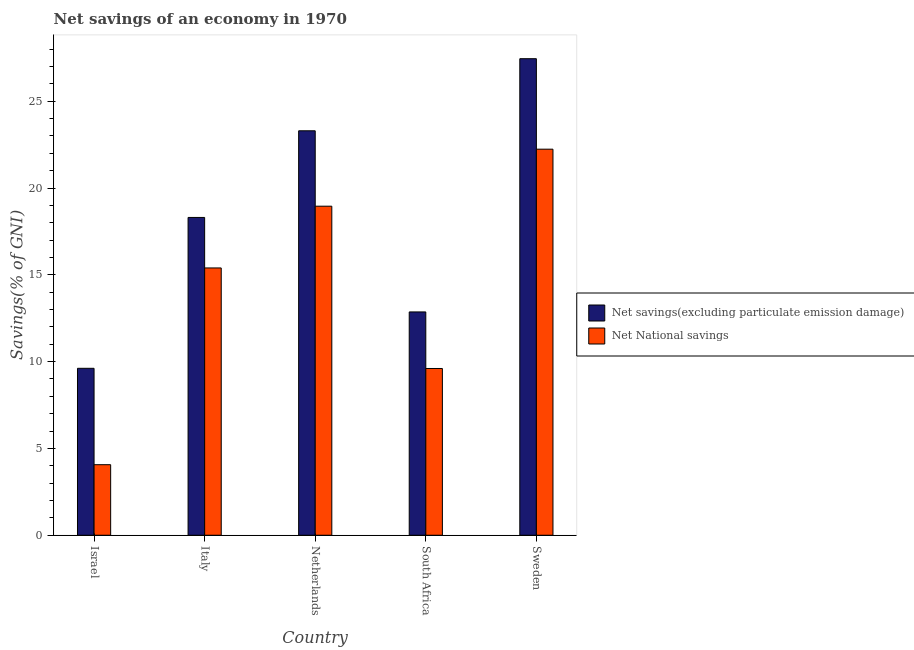How many different coloured bars are there?
Ensure brevity in your answer.  2. How many groups of bars are there?
Offer a terse response. 5. Are the number of bars per tick equal to the number of legend labels?
Provide a succinct answer. Yes. Are the number of bars on each tick of the X-axis equal?
Offer a terse response. Yes. How many bars are there on the 5th tick from the right?
Provide a succinct answer. 2. What is the label of the 5th group of bars from the left?
Give a very brief answer. Sweden. In how many cases, is the number of bars for a given country not equal to the number of legend labels?
Your answer should be compact. 0. What is the net savings(excluding particulate emission damage) in Netherlands?
Your answer should be very brief. 23.3. Across all countries, what is the maximum net national savings?
Keep it short and to the point. 22.24. Across all countries, what is the minimum net savings(excluding particulate emission damage)?
Your response must be concise. 9.61. In which country was the net savings(excluding particulate emission damage) maximum?
Your answer should be compact. Sweden. What is the total net savings(excluding particulate emission damage) in the graph?
Offer a terse response. 91.52. What is the difference between the net national savings in Italy and that in South Africa?
Keep it short and to the point. 5.79. What is the difference between the net national savings in Sweden and the net savings(excluding particulate emission damage) in South Africa?
Offer a terse response. 9.37. What is the average net savings(excluding particulate emission damage) per country?
Your answer should be very brief. 18.3. What is the difference between the net national savings and net savings(excluding particulate emission damage) in Italy?
Keep it short and to the point. -2.91. What is the ratio of the net savings(excluding particulate emission damage) in Italy to that in South Africa?
Your answer should be very brief. 1.42. Is the difference between the net savings(excluding particulate emission damage) in Israel and South Africa greater than the difference between the net national savings in Israel and South Africa?
Your answer should be compact. Yes. What is the difference between the highest and the second highest net national savings?
Your response must be concise. 3.28. What is the difference between the highest and the lowest net savings(excluding particulate emission damage)?
Your answer should be compact. 17.83. In how many countries, is the net national savings greater than the average net national savings taken over all countries?
Offer a terse response. 3. What does the 1st bar from the left in Sweden represents?
Your answer should be compact. Net savings(excluding particulate emission damage). What does the 2nd bar from the right in Italy represents?
Your answer should be very brief. Net savings(excluding particulate emission damage). How many bars are there?
Make the answer very short. 10. How many countries are there in the graph?
Your answer should be very brief. 5. What is the difference between two consecutive major ticks on the Y-axis?
Your answer should be compact. 5. Are the values on the major ticks of Y-axis written in scientific E-notation?
Keep it short and to the point. No. Does the graph contain any zero values?
Your answer should be very brief. No. Where does the legend appear in the graph?
Your answer should be very brief. Center right. How many legend labels are there?
Ensure brevity in your answer.  2. What is the title of the graph?
Your answer should be very brief. Net savings of an economy in 1970. What is the label or title of the X-axis?
Offer a terse response. Country. What is the label or title of the Y-axis?
Give a very brief answer. Savings(% of GNI). What is the Savings(% of GNI) in Net savings(excluding particulate emission damage) in Israel?
Offer a very short reply. 9.61. What is the Savings(% of GNI) in Net National savings in Israel?
Provide a succinct answer. 4.06. What is the Savings(% of GNI) in Net savings(excluding particulate emission damage) in Italy?
Keep it short and to the point. 18.3. What is the Savings(% of GNI) in Net National savings in Italy?
Offer a very short reply. 15.4. What is the Savings(% of GNI) in Net savings(excluding particulate emission damage) in Netherlands?
Provide a succinct answer. 23.3. What is the Savings(% of GNI) of Net National savings in Netherlands?
Make the answer very short. 18.95. What is the Savings(% of GNI) of Net savings(excluding particulate emission damage) in South Africa?
Your answer should be compact. 12.86. What is the Savings(% of GNI) of Net National savings in South Africa?
Make the answer very short. 9.6. What is the Savings(% of GNI) in Net savings(excluding particulate emission damage) in Sweden?
Offer a very short reply. 27.45. What is the Savings(% of GNI) in Net National savings in Sweden?
Offer a very short reply. 22.24. Across all countries, what is the maximum Savings(% of GNI) of Net savings(excluding particulate emission damage)?
Offer a terse response. 27.45. Across all countries, what is the maximum Savings(% of GNI) in Net National savings?
Give a very brief answer. 22.24. Across all countries, what is the minimum Savings(% of GNI) of Net savings(excluding particulate emission damage)?
Offer a very short reply. 9.61. Across all countries, what is the minimum Savings(% of GNI) of Net National savings?
Your response must be concise. 4.06. What is the total Savings(% of GNI) in Net savings(excluding particulate emission damage) in the graph?
Your answer should be compact. 91.52. What is the total Savings(% of GNI) of Net National savings in the graph?
Offer a very short reply. 70.25. What is the difference between the Savings(% of GNI) of Net savings(excluding particulate emission damage) in Israel and that in Italy?
Provide a succinct answer. -8.69. What is the difference between the Savings(% of GNI) in Net National savings in Israel and that in Italy?
Give a very brief answer. -11.33. What is the difference between the Savings(% of GNI) in Net savings(excluding particulate emission damage) in Israel and that in Netherlands?
Your answer should be very brief. -13.68. What is the difference between the Savings(% of GNI) of Net National savings in Israel and that in Netherlands?
Provide a succinct answer. -14.89. What is the difference between the Savings(% of GNI) of Net savings(excluding particulate emission damage) in Israel and that in South Africa?
Offer a very short reply. -3.25. What is the difference between the Savings(% of GNI) of Net National savings in Israel and that in South Africa?
Your response must be concise. -5.54. What is the difference between the Savings(% of GNI) in Net savings(excluding particulate emission damage) in Israel and that in Sweden?
Your answer should be very brief. -17.83. What is the difference between the Savings(% of GNI) of Net National savings in Israel and that in Sweden?
Provide a succinct answer. -18.17. What is the difference between the Savings(% of GNI) of Net savings(excluding particulate emission damage) in Italy and that in Netherlands?
Your answer should be compact. -4.99. What is the difference between the Savings(% of GNI) in Net National savings in Italy and that in Netherlands?
Offer a very short reply. -3.56. What is the difference between the Savings(% of GNI) in Net savings(excluding particulate emission damage) in Italy and that in South Africa?
Your response must be concise. 5.44. What is the difference between the Savings(% of GNI) in Net National savings in Italy and that in South Africa?
Offer a very short reply. 5.79. What is the difference between the Savings(% of GNI) of Net savings(excluding particulate emission damage) in Italy and that in Sweden?
Provide a short and direct response. -9.14. What is the difference between the Savings(% of GNI) in Net National savings in Italy and that in Sweden?
Your answer should be compact. -6.84. What is the difference between the Savings(% of GNI) in Net savings(excluding particulate emission damage) in Netherlands and that in South Africa?
Ensure brevity in your answer.  10.43. What is the difference between the Savings(% of GNI) of Net National savings in Netherlands and that in South Africa?
Provide a succinct answer. 9.35. What is the difference between the Savings(% of GNI) of Net savings(excluding particulate emission damage) in Netherlands and that in Sweden?
Provide a short and direct response. -4.15. What is the difference between the Savings(% of GNI) of Net National savings in Netherlands and that in Sweden?
Offer a very short reply. -3.28. What is the difference between the Savings(% of GNI) in Net savings(excluding particulate emission damage) in South Africa and that in Sweden?
Your answer should be very brief. -14.59. What is the difference between the Savings(% of GNI) in Net National savings in South Africa and that in Sweden?
Make the answer very short. -12.63. What is the difference between the Savings(% of GNI) in Net savings(excluding particulate emission damage) in Israel and the Savings(% of GNI) in Net National savings in Italy?
Provide a short and direct response. -5.78. What is the difference between the Savings(% of GNI) of Net savings(excluding particulate emission damage) in Israel and the Savings(% of GNI) of Net National savings in Netherlands?
Your response must be concise. -9.34. What is the difference between the Savings(% of GNI) of Net savings(excluding particulate emission damage) in Israel and the Savings(% of GNI) of Net National savings in South Africa?
Provide a short and direct response. 0.01. What is the difference between the Savings(% of GNI) of Net savings(excluding particulate emission damage) in Israel and the Savings(% of GNI) of Net National savings in Sweden?
Your answer should be very brief. -12.62. What is the difference between the Savings(% of GNI) of Net savings(excluding particulate emission damage) in Italy and the Savings(% of GNI) of Net National savings in Netherlands?
Give a very brief answer. -0.65. What is the difference between the Savings(% of GNI) of Net savings(excluding particulate emission damage) in Italy and the Savings(% of GNI) of Net National savings in South Africa?
Make the answer very short. 8.7. What is the difference between the Savings(% of GNI) in Net savings(excluding particulate emission damage) in Italy and the Savings(% of GNI) in Net National savings in Sweden?
Provide a short and direct response. -3.93. What is the difference between the Savings(% of GNI) of Net savings(excluding particulate emission damage) in Netherlands and the Savings(% of GNI) of Net National savings in South Africa?
Offer a very short reply. 13.69. What is the difference between the Savings(% of GNI) of Net savings(excluding particulate emission damage) in Netherlands and the Savings(% of GNI) of Net National savings in Sweden?
Your answer should be very brief. 1.06. What is the difference between the Savings(% of GNI) in Net savings(excluding particulate emission damage) in South Africa and the Savings(% of GNI) in Net National savings in Sweden?
Your answer should be compact. -9.37. What is the average Savings(% of GNI) in Net savings(excluding particulate emission damage) per country?
Keep it short and to the point. 18.3. What is the average Savings(% of GNI) in Net National savings per country?
Give a very brief answer. 14.05. What is the difference between the Savings(% of GNI) of Net savings(excluding particulate emission damage) and Savings(% of GNI) of Net National savings in Israel?
Provide a succinct answer. 5.55. What is the difference between the Savings(% of GNI) of Net savings(excluding particulate emission damage) and Savings(% of GNI) of Net National savings in Italy?
Your answer should be very brief. 2.91. What is the difference between the Savings(% of GNI) of Net savings(excluding particulate emission damage) and Savings(% of GNI) of Net National savings in Netherlands?
Keep it short and to the point. 4.34. What is the difference between the Savings(% of GNI) of Net savings(excluding particulate emission damage) and Savings(% of GNI) of Net National savings in South Africa?
Provide a short and direct response. 3.26. What is the difference between the Savings(% of GNI) of Net savings(excluding particulate emission damage) and Savings(% of GNI) of Net National savings in Sweden?
Your answer should be compact. 5.21. What is the ratio of the Savings(% of GNI) of Net savings(excluding particulate emission damage) in Israel to that in Italy?
Your answer should be compact. 0.53. What is the ratio of the Savings(% of GNI) in Net National savings in Israel to that in Italy?
Keep it short and to the point. 0.26. What is the ratio of the Savings(% of GNI) in Net savings(excluding particulate emission damage) in Israel to that in Netherlands?
Provide a short and direct response. 0.41. What is the ratio of the Savings(% of GNI) of Net National savings in Israel to that in Netherlands?
Ensure brevity in your answer.  0.21. What is the ratio of the Savings(% of GNI) of Net savings(excluding particulate emission damage) in Israel to that in South Africa?
Make the answer very short. 0.75. What is the ratio of the Savings(% of GNI) of Net National savings in Israel to that in South Africa?
Offer a terse response. 0.42. What is the ratio of the Savings(% of GNI) of Net savings(excluding particulate emission damage) in Israel to that in Sweden?
Offer a terse response. 0.35. What is the ratio of the Savings(% of GNI) in Net National savings in Israel to that in Sweden?
Offer a very short reply. 0.18. What is the ratio of the Savings(% of GNI) of Net savings(excluding particulate emission damage) in Italy to that in Netherlands?
Your answer should be compact. 0.79. What is the ratio of the Savings(% of GNI) in Net National savings in Italy to that in Netherlands?
Provide a succinct answer. 0.81. What is the ratio of the Savings(% of GNI) in Net savings(excluding particulate emission damage) in Italy to that in South Africa?
Your response must be concise. 1.42. What is the ratio of the Savings(% of GNI) of Net National savings in Italy to that in South Africa?
Give a very brief answer. 1.6. What is the ratio of the Savings(% of GNI) in Net savings(excluding particulate emission damage) in Italy to that in Sweden?
Offer a very short reply. 0.67. What is the ratio of the Savings(% of GNI) of Net National savings in Italy to that in Sweden?
Offer a very short reply. 0.69. What is the ratio of the Savings(% of GNI) in Net savings(excluding particulate emission damage) in Netherlands to that in South Africa?
Your response must be concise. 1.81. What is the ratio of the Savings(% of GNI) in Net National savings in Netherlands to that in South Africa?
Ensure brevity in your answer.  1.97. What is the ratio of the Savings(% of GNI) in Net savings(excluding particulate emission damage) in Netherlands to that in Sweden?
Make the answer very short. 0.85. What is the ratio of the Savings(% of GNI) of Net National savings in Netherlands to that in Sweden?
Your answer should be very brief. 0.85. What is the ratio of the Savings(% of GNI) of Net savings(excluding particulate emission damage) in South Africa to that in Sweden?
Offer a terse response. 0.47. What is the ratio of the Savings(% of GNI) of Net National savings in South Africa to that in Sweden?
Offer a very short reply. 0.43. What is the difference between the highest and the second highest Savings(% of GNI) of Net savings(excluding particulate emission damage)?
Give a very brief answer. 4.15. What is the difference between the highest and the second highest Savings(% of GNI) in Net National savings?
Your answer should be compact. 3.28. What is the difference between the highest and the lowest Savings(% of GNI) of Net savings(excluding particulate emission damage)?
Your response must be concise. 17.83. What is the difference between the highest and the lowest Savings(% of GNI) of Net National savings?
Give a very brief answer. 18.17. 